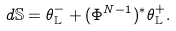<formula> <loc_0><loc_0><loc_500><loc_500>d \mathbb { S } = \theta _ { \mathbb { L } } ^ { - } + ( \Phi ^ { N - 1 } ) ^ { * } \theta _ { \mathbb { L } } ^ { + } .</formula> 